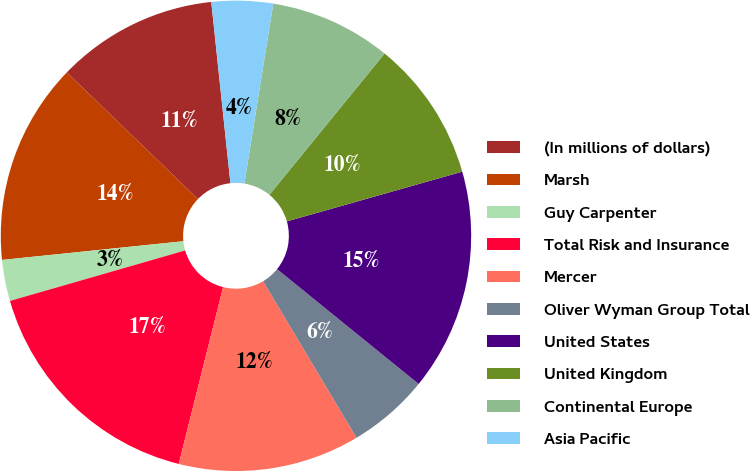<chart> <loc_0><loc_0><loc_500><loc_500><pie_chart><fcel>(In millions of dollars)<fcel>Marsh<fcel>Guy Carpenter<fcel>Total Risk and Insurance<fcel>Mercer<fcel>Oliver Wyman Group Total<fcel>United States<fcel>United Kingdom<fcel>Continental Europe<fcel>Asia Pacific<nl><fcel>11.1%<fcel>13.86%<fcel>2.83%<fcel>16.62%<fcel>12.48%<fcel>5.59%<fcel>15.24%<fcel>9.72%<fcel>8.35%<fcel>4.21%<nl></chart> 